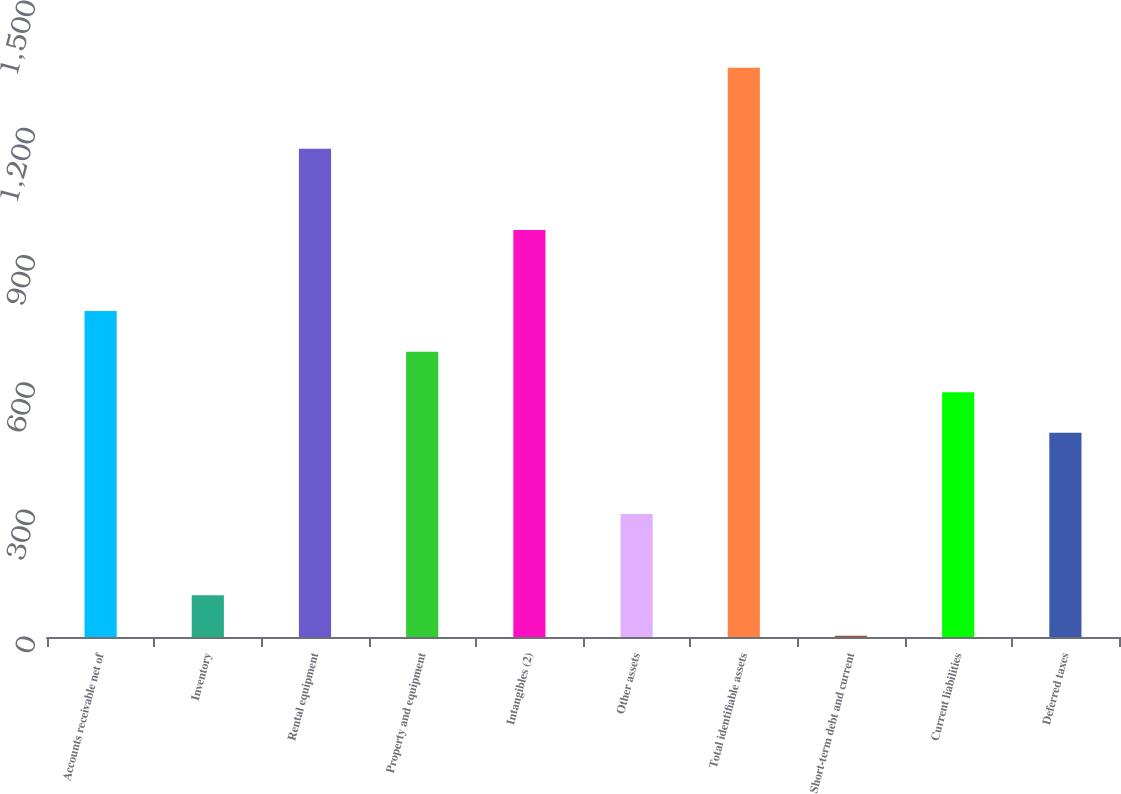Convert chart. <chart><loc_0><loc_0><loc_500><loc_500><bar_chart><fcel>Accounts receivable net of<fcel>Inventory<fcel>Rental equipment<fcel>Property and equipment<fcel>Intangibles (2)<fcel>Other assets<fcel>Total identifiable assets<fcel>Short-term debt and current<fcel>Current liabilities<fcel>Deferred taxes<nl><fcel>768.6<fcel>98.7<fcel>1151.4<fcel>672.9<fcel>960<fcel>290.1<fcel>1342.8<fcel>3<fcel>577.2<fcel>481.5<nl></chart> 